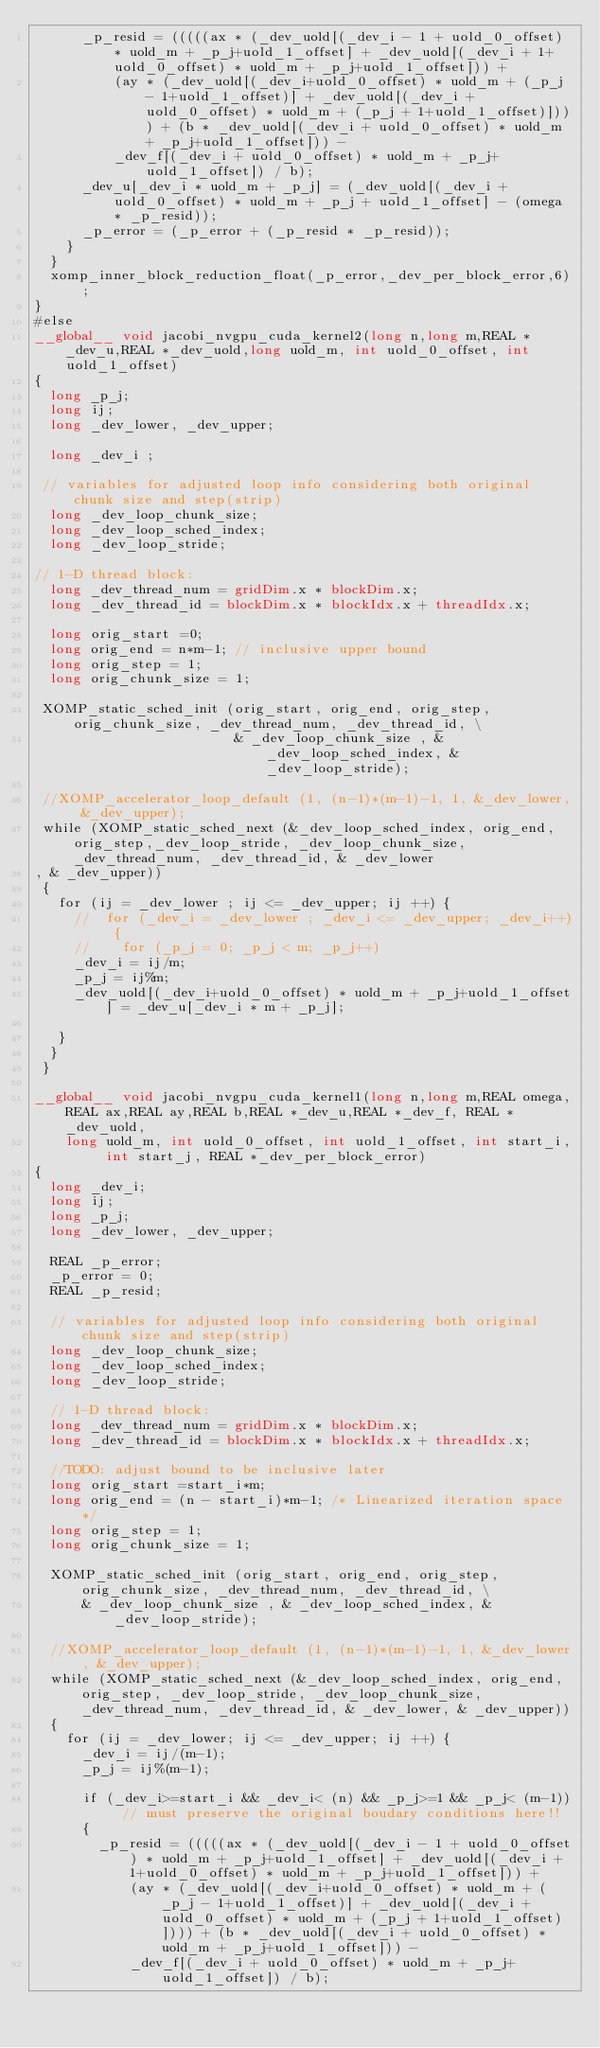<code> <loc_0><loc_0><loc_500><loc_500><_Cuda_>      _p_resid = (((((ax * (_dev_uold[(_dev_i - 1 + uold_0_offset) * uold_m + _p_j+uold_1_offset] + _dev_uold[(_dev_i + 1+uold_0_offset) * uold_m + _p_j+uold_1_offset])) +
    		  (ay * (_dev_uold[(_dev_i+uold_0_offset) * uold_m + (_p_j - 1+uold_1_offset)] + _dev_uold[(_dev_i + uold_0_offset) * uold_m + (_p_j + 1+uold_1_offset)]))) + (b * _dev_uold[(_dev_i + uold_0_offset) * uold_m + _p_j+uold_1_offset])) -
    		  _dev_f[(_dev_i + uold_0_offset) * uold_m + _p_j+uold_1_offset]) / b);
      _dev_u[_dev_i * uold_m + _p_j] = (_dev_uold[(_dev_i + uold_0_offset) * uold_m + _p_j + uold_1_offset] - (omega * _p_resid));
      _p_error = (_p_error + (_p_resid * _p_resid));
    }
  }
  xomp_inner_block_reduction_float(_p_error,_dev_per_block_error,6);
}
#else
__global__ void jacobi_nvgpu_cuda_kernel2(long n,long m,REAL *_dev_u,REAL *_dev_uold,long uold_m, int uold_0_offset, int uold_1_offset)
{
	long _p_j;
	long ij;
	long _dev_lower, _dev_upper;

	long _dev_i ;

 // variables for adjusted loop info considering both original chunk size and step(strip)
	long _dev_loop_chunk_size;
	long _dev_loop_sched_index;
	long _dev_loop_stride;

// 1-D thread block:
	long _dev_thread_num = gridDim.x * blockDim.x;
	long _dev_thread_id = blockDim.x * blockIdx.x + threadIdx.x;

	long orig_start =0;
	long orig_end = n*m-1; // inclusive upper bound
	long orig_step = 1;
	long orig_chunk_size = 1;

 XOMP_static_sched_init (orig_start, orig_end, orig_step, orig_chunk_size, _dev_thread_num, _dev_thread_id, \
                         & _dev_loop_chunk_size , & _dev_loop_sched_index, & _dev_loop_stride);

 //XOMP_accelerator_loop_default (1, (n-1)*(m-1)-1, 1, &_dev_lower, &_dev_upper);
 while (XOMP_static_sched_next (&_dev_loop_sched_index, orig_end, orig_step,_dev_loop_stride, _dev_loop_chunk_size, _dev_thread_num, _dev_thread_id, & _dev_lower
, & _dev_upper))
 {
   for (ij = _dev_lower ; ij <= _dev_upper; ij ++) {
     //  for (_dev_i = _dev_lower ; _dev_i <= _dev_upper; _dev_i++) {
     //    for (_p_j = 0; _p_j < m; _p_j++)
     _dev_i = ij/m;
     _p_j = ij%m;
     _dev_uold[(_dev_i+uold_0_offset) * uold_m + _p_j+uold_1_offset] = _dev_u[_dev_i * m + _p_j];

   }
  }
 }

__global__ void jacobi_nvgpu_cuda_kernel1(long n,long m,REAL omega,REAL ax,REAL ay,REAL b,REAL *_dev_u,REAL *_dev_f, REAL *_dev_uold,
		long uold_m, int uold_0_offset, int uold_1_offset, int start_i, int start_j, REAL *_dev_per_block_error)
{
	long _dev_i;
	long ij;
	long _p_j;
	long _dev_lower, _dev_upper;

  REAL _p_error;
  _p_error = 0;
  REAL _p_resid;

  // variables for adjusted loop info considering both original chunk size and step(strip)
  long _dev_loop_chunk_size;
  long _dev_loop_sched_index;
  long _dev_loop_stride;

  // 1-D thread block:
  long _dev_thread_num = gridDim.x * blockDim.x;
  long _dev_thread_id = blockDim.x * blockIdx.x + threadIdx.x;

  //TODO: adjust bound to be inclusive later
  long orig_start =start_i*m;
  long orig_end = (n - start_i)*m-1; /* Linearized iteration space */
  long orig_step = 1;
  long orig_chunk_size = 1;

  XOMP_static_sched_init (orig_start, orig_end, orig_step, orig_chunk_size, _dev_thread_num, _dev_thread_id, \
      & _dev_loop_chunk_size , & _dev_loop_sched_index, & _dev_loop_stride);

  //XOMP_accelerator_loop_default (1, (n-1)*(m-1)-1, 1, &_dev_lower, &_dev_upper);
  while (XOMP_static_sched_next (&_dev_loop_sched_index, orig_end,orig_step, _dev_loop_stride, _dev_loop_chunk_size, _dev_thread_num, _dev_thread_id, & _dev_lower, & _dev_upper))
  {
    for (ij = _dev_lower; ij <= _dev_upper; ij ++) {
      _dev_i = ij/(m-1);
      _p_j = ij%(m-1);

      if (_dev_i>=start_i && _dev_i< (n) && _p_j>=1 && _p_j< (m-1)) // must preserve the original boudary conditions here!!
      {
    	  _p_resid = (((((ax * (_dev_uold[(_dev_i - 1 + uold_0_offset) * uold_m + _p_j+uold_1_offset] + _dev_uold[(_dev_i + 1+uold_0_offset) * uold_m + _p_j+uold_1_offset])) +
	    		  (ay * (_dev_uold[(_dev_i+uold_0_offset) * uold_m + (_p_j - 1+uold_1_offset)] + _dev_uold[(_dev_i + uold_0_offset) * uold_m + (_p_j + 1+uold_1_offset)]))) + (b * _dev_uold[(_dev_i + uold_0_offset) * uold_m + _p_j+uold_1_offset])) -
	    		  _dev_f[(_dev_i + uold_0_offset) * uold_m + _p_j+uold_1_offset]) / b);</code> 